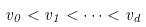<formula> <loc_0><loc_0><loc_500><loc_500>v _ { 0 } < v _ { 1 } < \dots < v _ { d }</formula> 